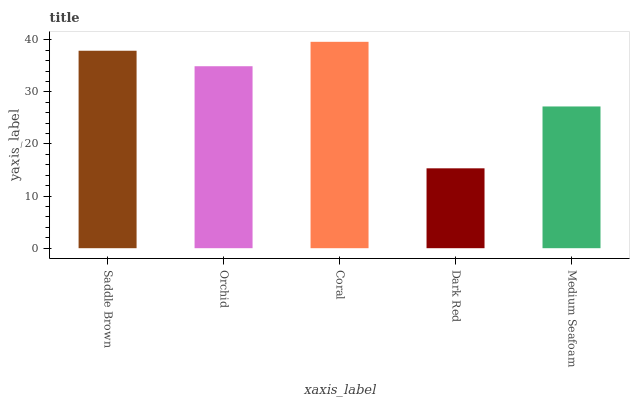Is Dark Red the minimum?
Answer yes or no. Yes. Is Coral the maximum?
Answer yes or no. Yes. Is Orchid the minimum?
Answer yes or no. No. Is Orchid the maximum?
Answer yes or no. No. Is Saddle Brown greater than Orchid?
Answer yes or no. Yes. Is Orchid less than Saddle Brown?
Answer yes or no. Yes. Is Orchid greater than Saddle Brown?
Answer yes or no. No. Is Saddle Brown less than Orchid?
Answer yes or no. No. Is Orchid the high median?
Answer yes or no. Yes. Is Orchid the low median?
Answer yes or no. Yes. Is Saddle Brown the high median?
Answer yes or no. No. Is Dark Red the low median?
Answer yes or no. No. 